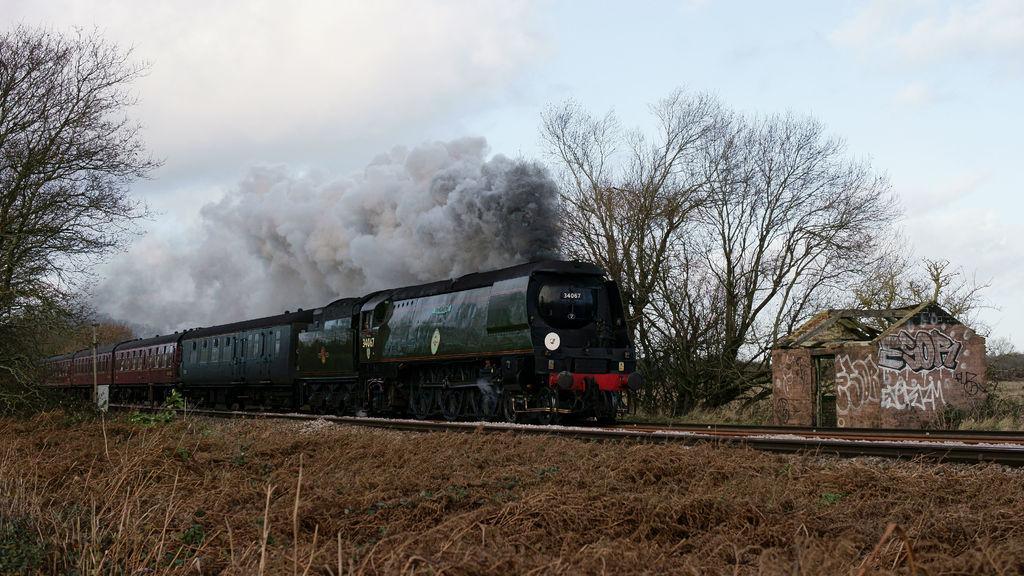Describe this image in one or two sentences. In this picture there is a train moving on the track. In the front there is a dry grass. Behind there are dry trees and small shed house. 